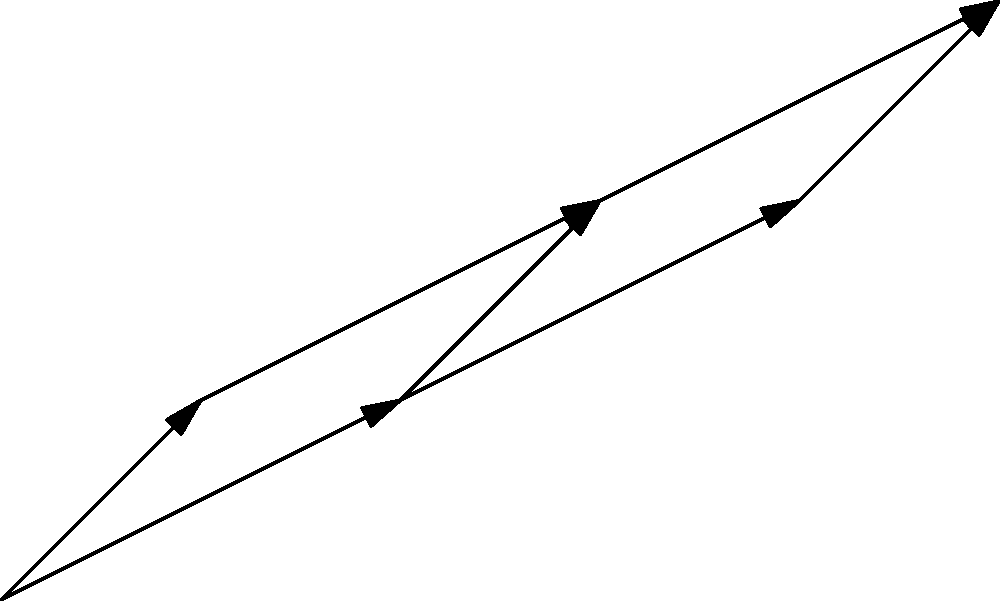In a multi-table poker tournament, the directed acyclic graph represents different stages and possible paths a player can take. Each node represents a table, and the edges represent the progression between tables with associated chip stack increases (in thousands). What is the maximum chip stack (in thousands) a player can accumulate by following the optimal path from the starting table (node 1) to the final table (node 6)? To find the maximum chip stack, we need to determine the path that yields the highest total chip increase. We'll use dynamic programming to solve this problem:

1. Start at node 1 (the initial table).
2. For each node, calculate the maximum chip stack that can be reached:

   Node 1: 0 (starting point)
   Node 2: 50 (path 1 → 2)
   Node 3: 30 (path 1 → 3)
   Node 4: max(50 + 80, 30 + 40) = 130 (path 1 → 2 → 4)
   Node 5: 30 + 60 = 90 (path 1 → 3 → 5)
   Node 6: max(130 + 100, 90 + 70) = 230 (path 1 → 2 → 4 → 6)

3. The maximum chip stack at the final table (node 6) is 230 thousand.

The optimal path is 1 → 2 → 4 → 6, accumulating 50 + 80 + 100 = 230 thousand chips.
Answer: 230 thousand chips 